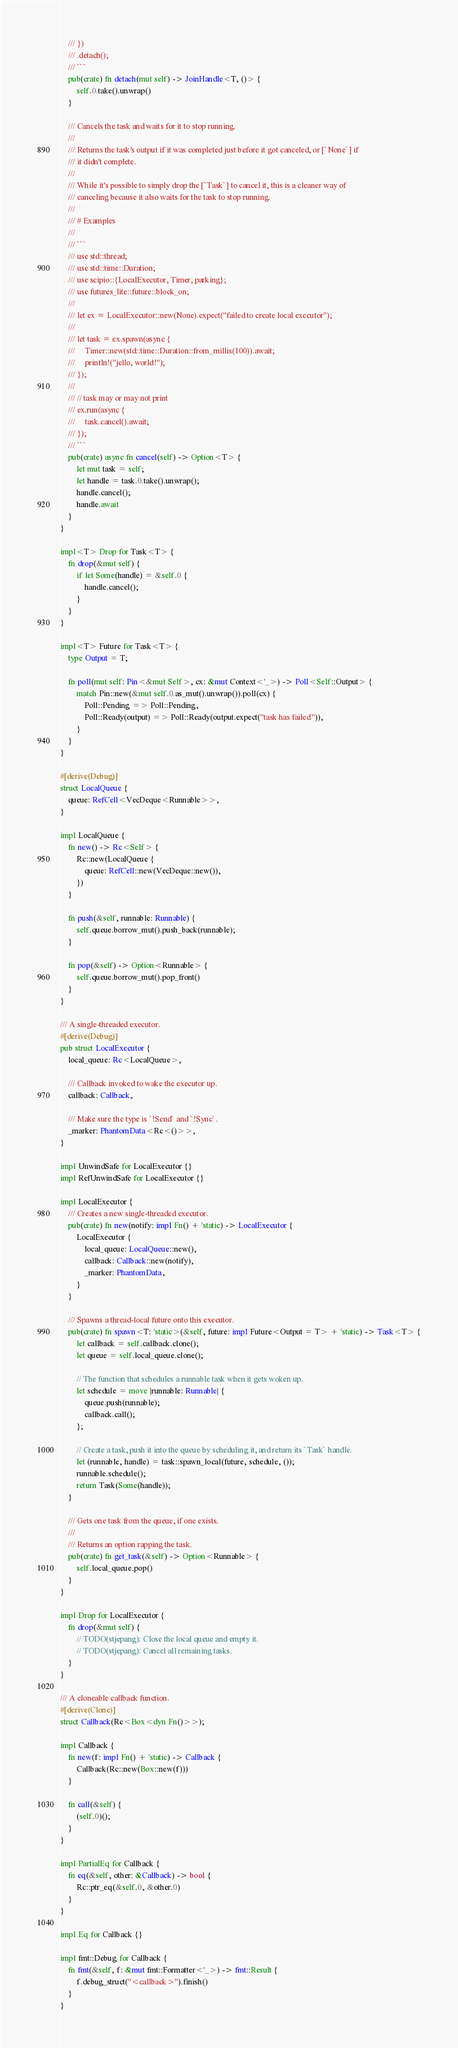Convert code to text. <code><loc_0><loc_0><loc_500><loc_500><_Rust_>    /// })
    /// .detach();
    /// ```
    pub(crate) fn detach(mut self) -> JoinHandle<T, ()> {
        self.0.take().unwrap()
    }

    /// Cancels the task and waits for it to stop running.
    ///
    /// Returns the task's output if it was completed just before it got canceled, or [`None`] if
    /// it didn't complete.
    ///
    /// While it's possible to simply drop the [`Task`] to cancel it, this is a cleaner way of
    /// canceling because it also waits for the task to stop running.
    ///
    /// # Examples
    ///
    /// ```
    /// use std::thread;
    /// use std::time::Duration;
    /// use scipio::{LocalExecutor, Timer, parking};
    /// use futures_lite::future::block_on;
    ///
    /// let ex = LocalExecutor::new(None).expect("failed to create local executor");
    ///
    /// let task = ex.spawn(async {
    ///     Timer::new(std::time::Duration::from_millis(100)).await;
    ///     println!("jello, world!");
    /// });
    ///
    /// // task may or may not print
    /// ex.run(async {
    ///     task.cancel().await;
    /// });
    /// ```
    pub(crate) async fn cancel(self) -> Option<T> {
        let mut task = self;
        let handle = task.0.take().unwrap();
        handle.cancel();
        handle.await
    }
}

impl<T> Drop for Task<T> {
    fn drop(&mut self) {
        if let Some(handle) = &self.0 {
            handle.cancel();
        }
    }
}

impl<T> Future for Task<T> {
    type Output = T;

    fn poll(mut self: Pin<&mut Self>, cx: &mut Context<'_>) -> Poll<Self::Output> {
        match Pin::new(&mut self.0.as_mut().unwrap()).poll(cx) {
            Poll::Pending => Poll::Pending,
            Poll::Ready(output) => Poll::Ready(output.expect("task has failed")),
        }
    }
}

#[derive(Debug)]
struct LocalQueue {
    queue: RefCell<VecDeque<Runnable>>,
}

impl LocalQueue {
    fn new() -> Rc<Self> {
        Rc::new(LocalQueue {
            queue: RefCell::new(VecDeque::new()),
        })
    }

    fn push(&self, runnable: Runnable) {
        self.queue.borrow_mut().push_back(runnable);
    }

    fn pop(&self) -> Option<Runnable> {
        self.queue.borrow_mut().pop_front()
    }
}

/// A single-threaded executor.
#[derive(Debug)]
pub struct LocalExecutor {
    local_queue: Rc<LocalQueue>,

    /// Callback invoked to wake the executor up.
    callback: Callback,

    /// Make sure the type is `!Send` and `!Sync`.
    _marker: PhantomData<Rc<()>>,
}

impl UnwindSafe for LocalExecutor {}
impl RefUnwindSafe for LocalExecutor {}

impl LocalExecutor {
    /// Creates a new single-threaded executor.
    pub(crate) fn new(notify: impl Fn() + 'static) -> LocalExecutor {
        LocalExecutor {
            local_queue: LocalQueue::new(),
            callback: Callback::new(notify),
            _marker: PhantomData,
        }
    }

    /// Spawns a thread-local future onto this executor.
    pub(crate) fn spawn<T: 'static>(&self, future: impl Future<Output = T> + 'static) -> Task<T> {
        let callback = self.callback.clone();
        let queue = self.local_queue.clone();

        // The function that schedules a runnable task when it gets woken up.
        let schedule = move |runnable: Runnable| {
            queue.push(runnable);
            callback.call();
        };

        // Create a task, push it into the queue by scheduling it, and return its `Task` handle.
        let (runnable, handle) = task::spawn_local(future, schedule, ());
        runnable.schedule();
        return Task(Some(handle));
    }

    /// Gets one task from the queue, if one exists.
    ///
    /// Returns an option rapping the task.
    pub(crate) fn get_task(&self) -> Option<Runnable> {
        self.local_queue.pop()
    }
}

impl Drop for LocalExecutor {
    fn drop(&mut self) {
        // TODO(stjepang): Close the local queue and empty it.
        // TODO(stjepang): Cancel all remaining tasks.
    }
}

/// A cloneable callback function.
#[derive(Clone)]
struct Callback(Rc<Box<dyn Fn()>>);

impl Callback {
    fn new(f: impl Fn() + 'static) -> Callback {
        Callback(Rc::new(Box::new(f)))
    }

    fn call(&self) {
        (self.0)();
    }
}

impl PartialEq for Callback {
    fn eq(&self, other: &Callback) -> bool {
        Rc::ptr_eq(&self.0, &other.0)
    }
}

impl Eq for Callback {}

impl fmt::Debug for Callback {
    fn fmt(&self, f: &mut fmt::Formatter<'_>) -> fmt::Result {
        f.debug_struct("<callback>").finish()
    }
}
</code> 